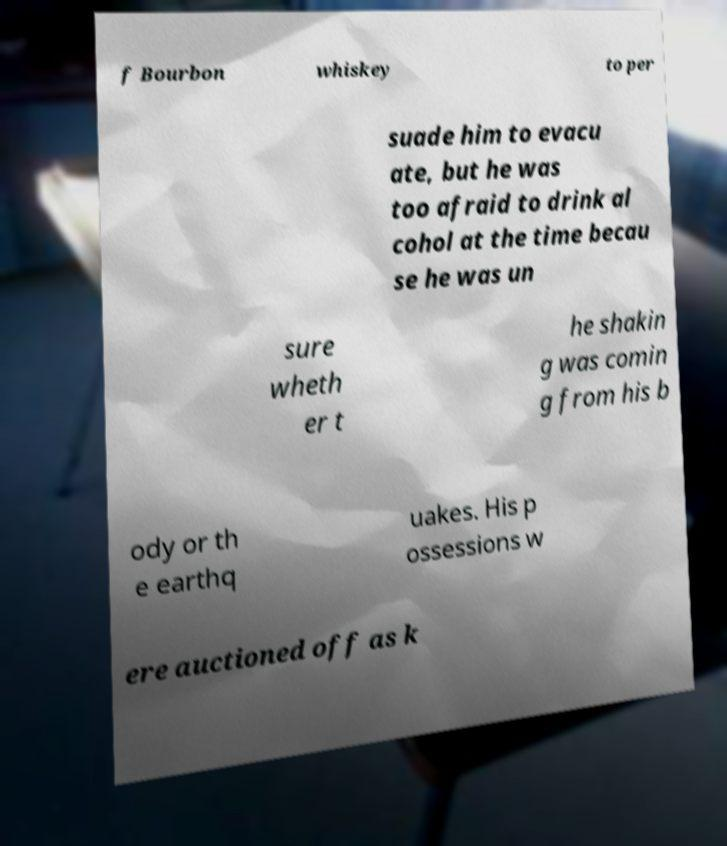Please identify and transcribe the text found in this image. f Bourbon whiskey to per suade him to evacu ate, but he was too afraid to drink al cohol at the time becau se he was un sure wheth er t he shakin g was comin g from his b ody or th e earthq uakes. His p ossessions w ere auctioned off as k 